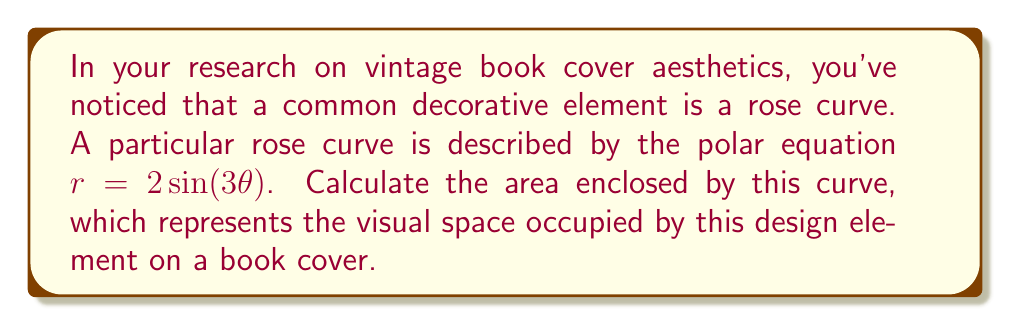Provide a solution to this math problem. To calculate the area enclosed by a polar curve, we use the formula:

$$ A = \frac{1}{2} \int_0^{2\pi} r^2 d\theta $$

For our rose curve $r = 2\sin(3\theta)$, we need to:

1) Square $r$:
   $r^2 = 4\sin^2(3\theta)$

2) Substitute this into our integral:
   $$ A = \frac{1}{2} \int_0^{2\pi} 4\sin^2(3\theta) d\theta $$

3) Use the trigonometric identity $\sin^2(x) = \frac{1 - \cos(2x)}{2}$:
   $$ A = \frac{1}{2} \int_0^{2\pi} 4 \cdot \frac{1 - \cos(6\theta)}{2} d\theta $$

4) Simplify:
   $$ A = \int_0^{2\pi} 1 - \cos(6\theta) d\theta $$

5) Integrate:
   $$ A = [\theta - \frac{1}{6}\sin(6\theta)]_0^{2\pi} $$

6) Evaluate the integral:
   $$ A = (2\pi - 0) - (\frac{1}{6}\sin(12\pi) - \frac{1}{6}\sin(0)) = 2\pi $$

Therefore, the area enclosed by the rose curve is $2\pi$ square units.

[asy]
import graph;
size(200);
real r(real t) {return 2*sin(3*t);}
path g=polargraph(r,0,2pi);
draw(g,red);
xaxis(arrow=Arrow);
yaxis(arrow=Arrow);
label("$x$",(1.1,0),E);
label("$y$",(0,1.1),N);
[/asy]
Answer: $2\pi$ square units 